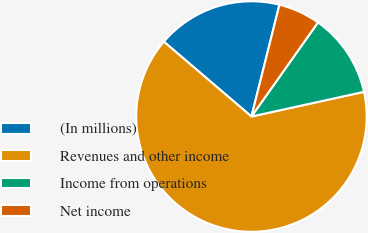<chart> <loc_0><loc_0><loc_500><loc_500><pie_chart><fcel>(In millions)<fcel>Revenues and other income<fcel>Income from operations<fcel>Net income<nl><fcel>17.65%<fcel>64.69%<fcel>11.77%<fcel>5.89%<nl></chart> 